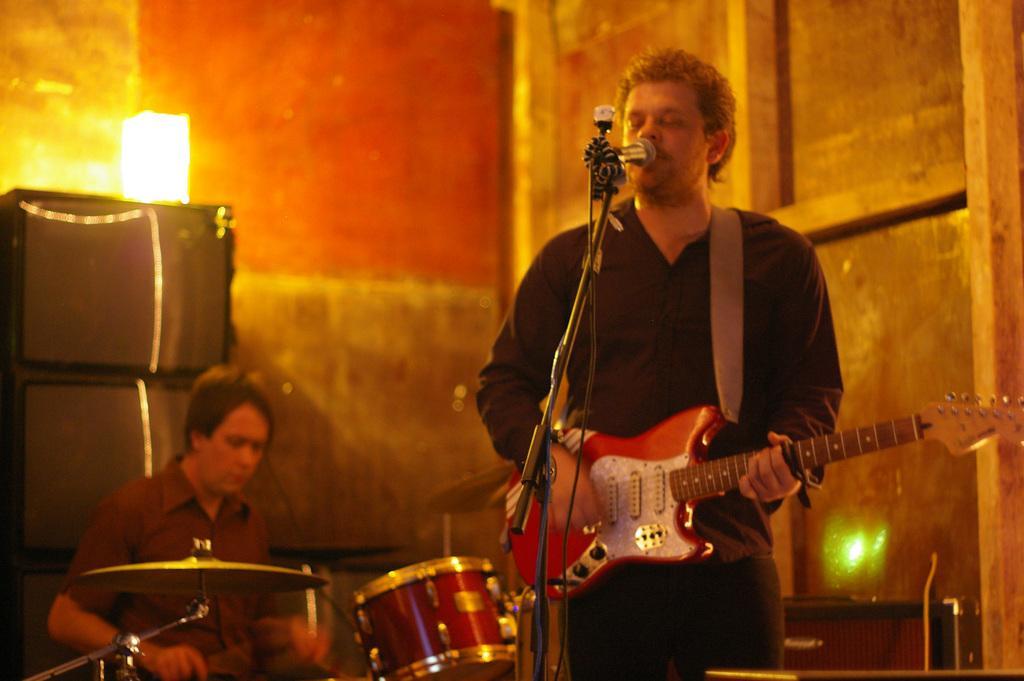In one or two sentences, can you explain what this image depicts? It is a music show there are total two people in the image, the first person is wearing a guitar and is also singing a song, the man behind him is sitting and playing the drums , in the background there is a lamp, speakers ,to the right side there is a wooden wall. 